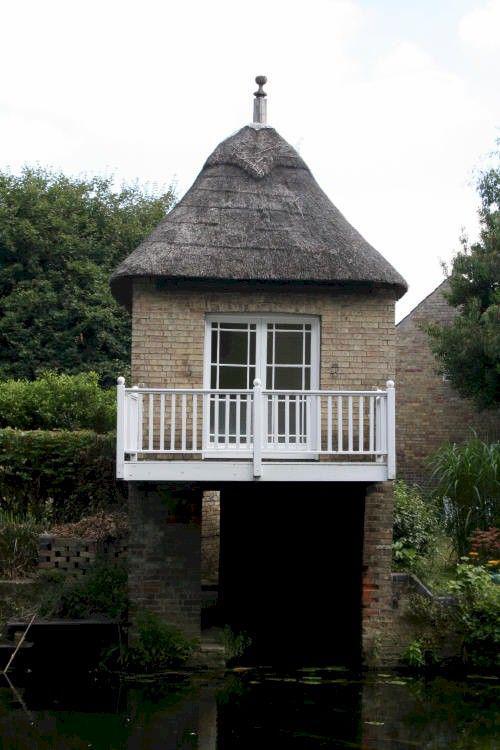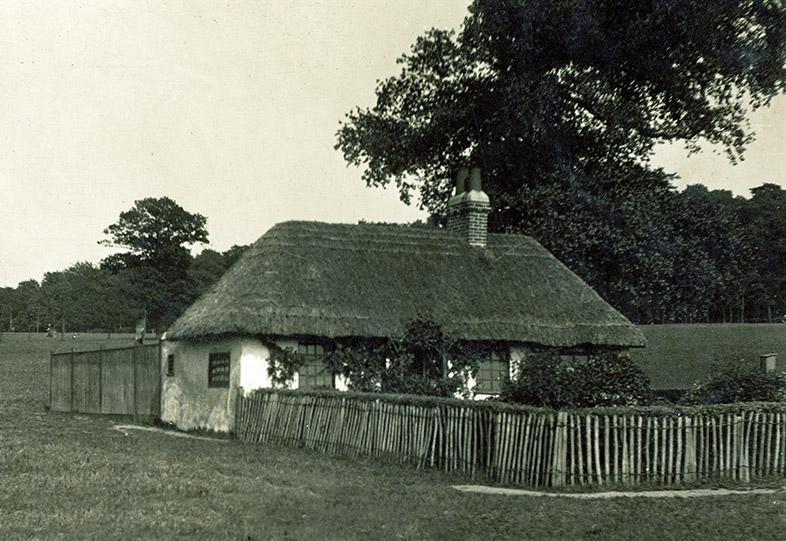The first image is the image on the left, the second image is the image on the right. Analyze the images presented: Is the assertion "There is exactly one brick chimney." valid? Answer yes or no. Yes. The first image is the image on the left, the second image is the image on the right. For the images displayed, is the sentence "The roof in the left image is straight across the bottom and forms a simple triangle shape." factually correct? Answer yes or no. Yes. 